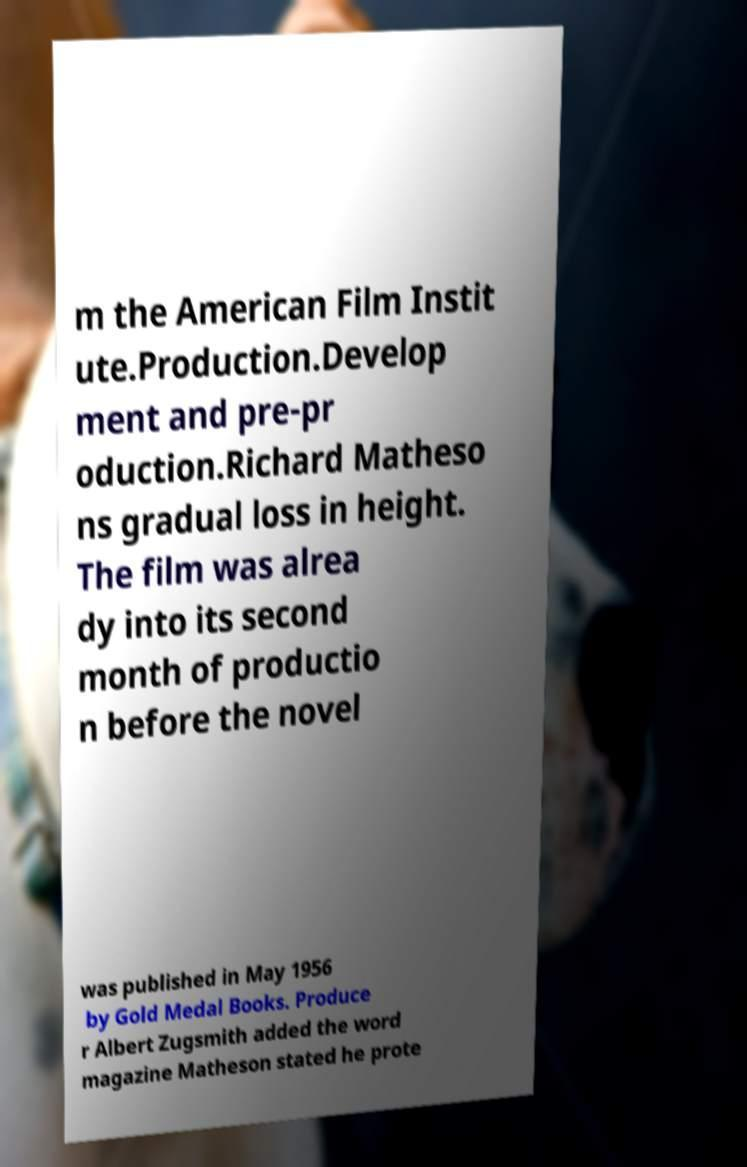Please identify and transcribe the text found in this image. m the American Film Instit ute.Production.Develop ment and pre-pr oduction.Richard Matheso ns gradual loss in height. The film was alrea dy into its second month of productio n before the novel was published in May 1956 by Gold Medal Books. Produce r Albert Zugsmith added the word magazine Matheson stated he prote 